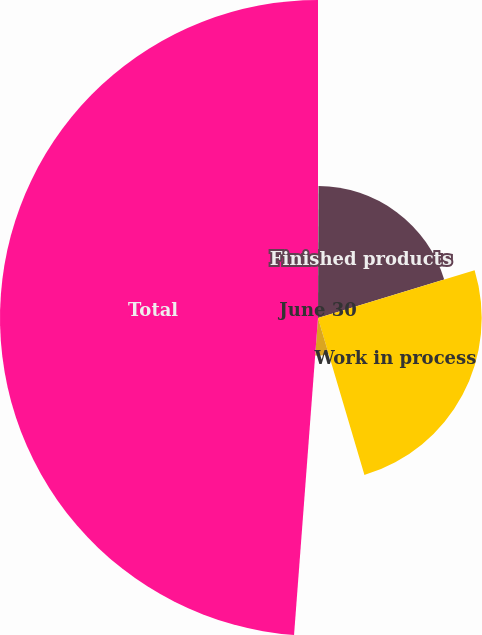<chart> <loc_0><loc_0><loc_500><loc_500><pie_chart><fcel>June 30<fcel>Finished products<fcel>Work in process<fcel>Raw materials<fcel>Total<nl><fcel>0.06%<fcel>20.24%<fcel>25.12%<fcel>5.78%<fcel>48.8%<nl></chart> 